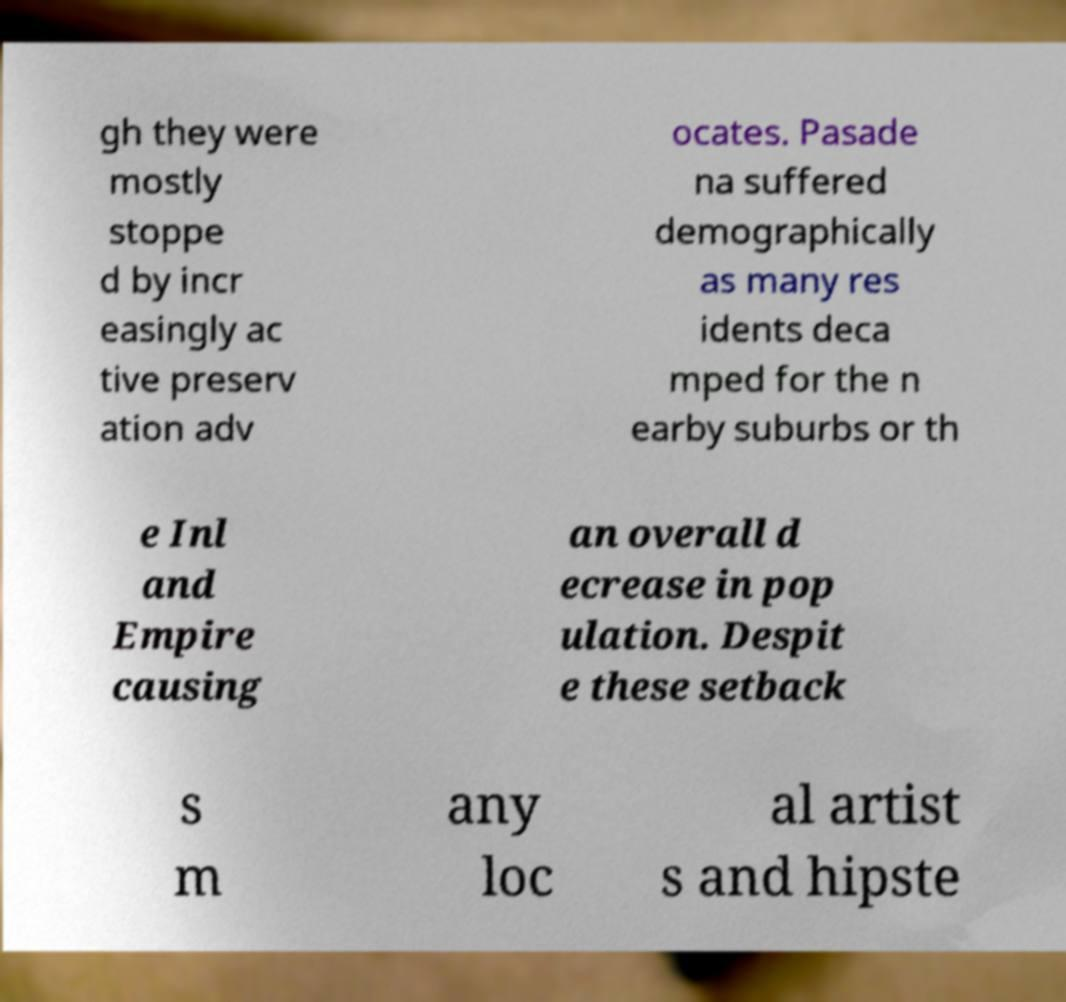For documentation purposes, I need the text within this image transcribed. Could you provide that? gh they were mostly stoppe d by incr easingly ac tive preserv ation adv ocates. Pasade na suffered demographically as many res idents deca mped for the n earby suburbs or th e Inl and Empire causing an overall d ecrease in pop ulation. Despit e these setback s m any loc al artist s and hipste 